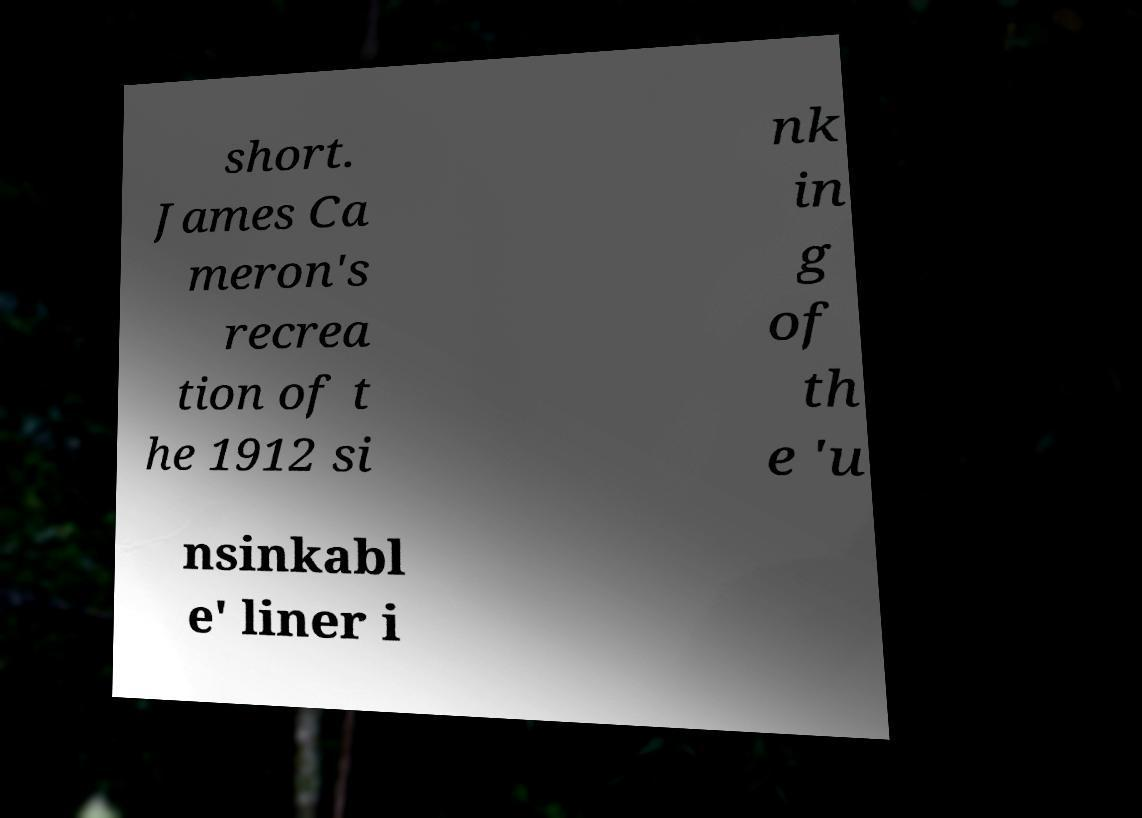Please read and relay the text visible in this image. What does it say? short. James Ca meron's recrea tion of t he 1912 si nk in g of th e 'u nsinkabl e' liner i 